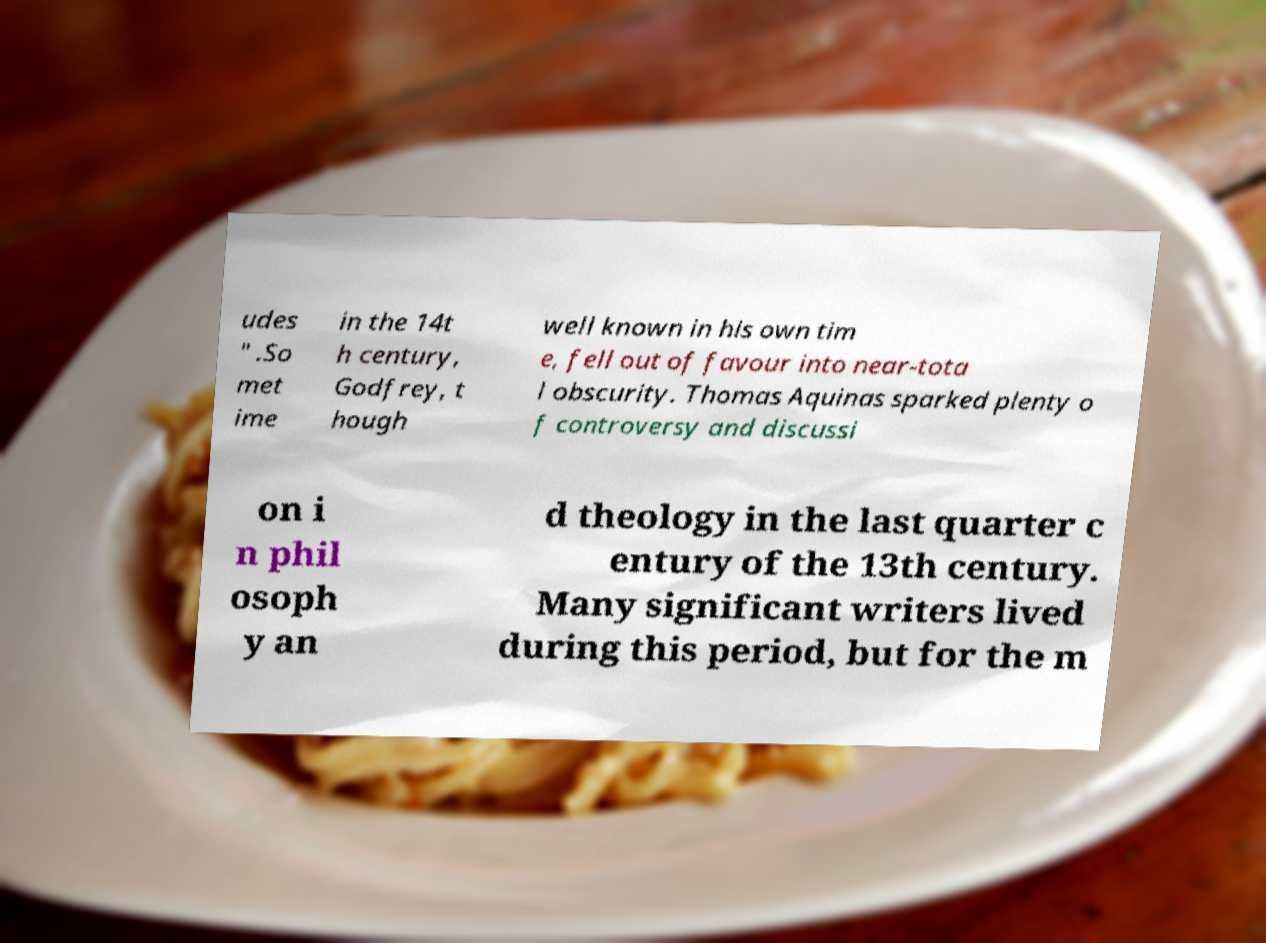I need the written content from this picture converted into text. Can you do that? udes " .So met ime in the 14t h century, Godfrey, t hough well known in his own tim e, fell out of favour into near-tota l obscurity. Thomas Aquinas sparked plenty o f controversy and discussi on i n phil osoph y an d theology in the last quarter c entury of the 13th century. Many significant writers lived during this period, but for the m 